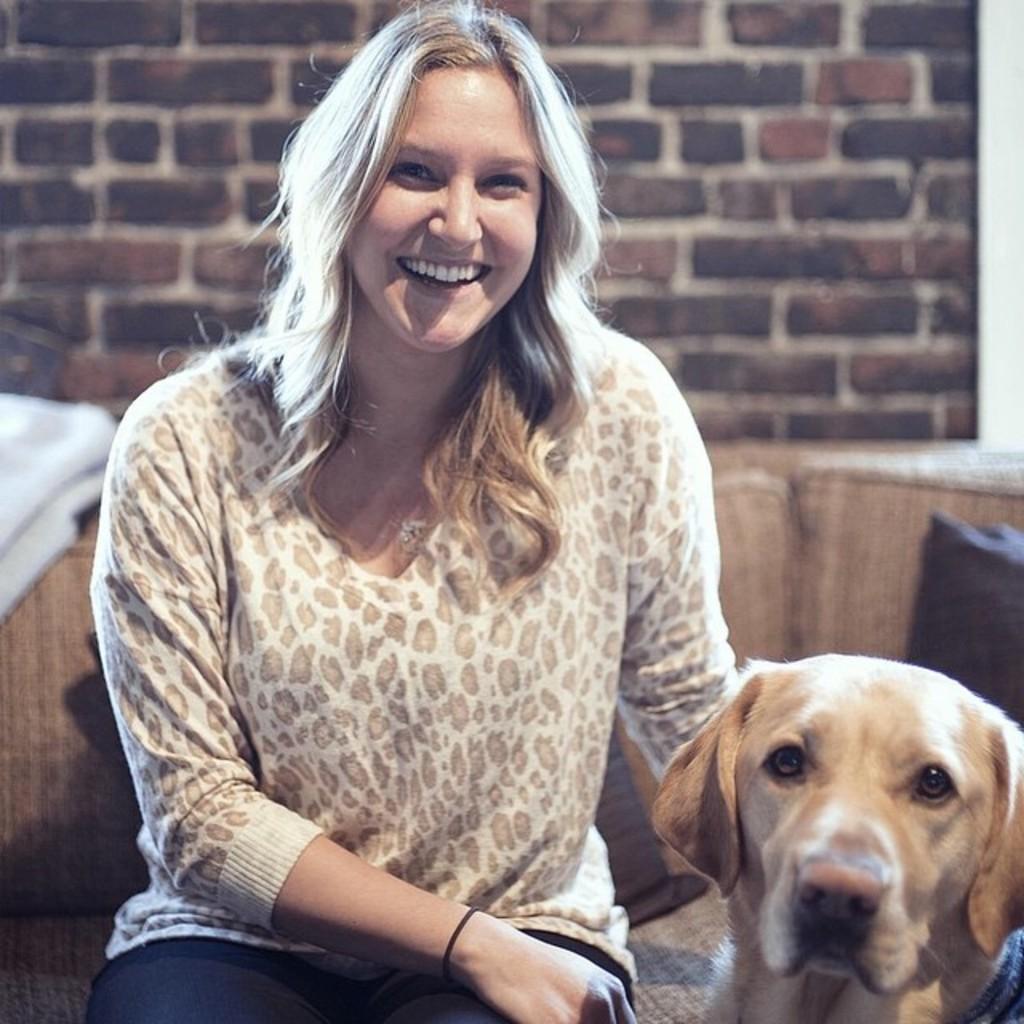Could you give a brief overview of what you see in this image? In the picture we can see a woman sitting on a sofa and smiling and beside her we can see a dog and behind the sofa we can see a wall with bricks. 